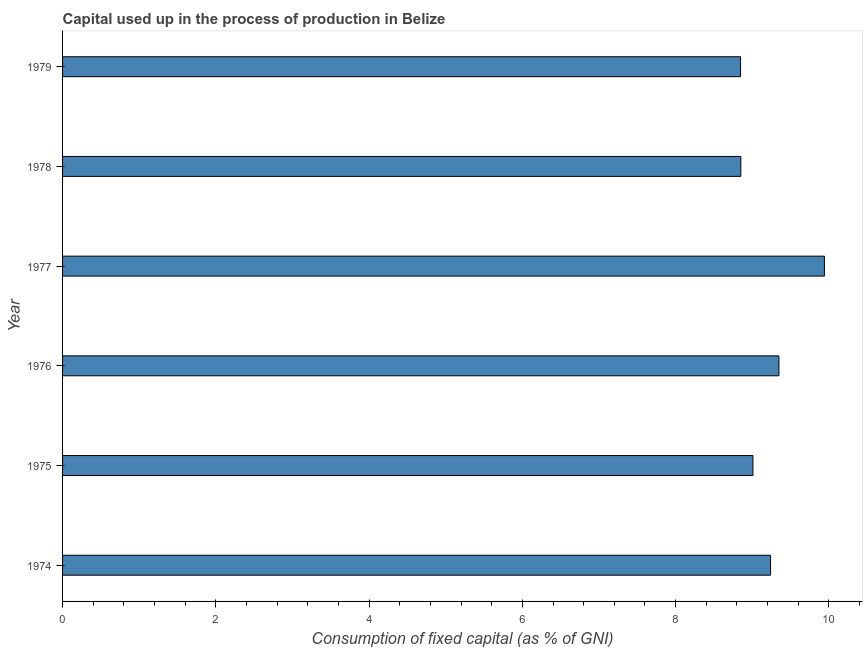Does the graph contain any zero values?
Offer a terse response. No. What is the title of the graph?
Ensure brevity in your answer.  Capital used up in the process of production in Belize. What is the label or title of the X-axis?
Provide a succinct answer. Consumption of fixed capital (as % of GNI). What is the label or title of the Y-axis?
Provide a short and direct response. Year. What is the consumption of fixed capital in 1977?
Give a very brief answer. 9.94. Across all years, what is the maximum consumption of fixed capital?
Provide a short and direct response. 9.94. Across all years, what is the minimum consumption of fixed capital?
Offer a terse response. 8.85. In which year was the consumption of fixed capital maximum?
Offer a terse response. 1977. In which year was the consumption of fixed capital minimum?
Ensure brevity in your answer.  1979. What is the sum of the consumption of fixed capital?
Your answer should be very brief. 55.23. What is the difference between the consumption of fixed capital in 1974 and 1979?
Give a very brief answer. 0.39. What is the average consumption of fixed capital per year?
Your answer should be compact. 9.21. What is the median consumption of fixed capital?
Give a very brief answer. 9.12. Do a majority of the years between 1977 and 1974 (inclusive) have consumption of fixed capital greater than 8.4 %?
Your answer should be compact. Yes. What is the ratio of the consumption of fixed capital in 1974 to that in 1979?
Give a very brief answer. 1.04. Is the consumption of fixed capital in 1975 less than that in 1979?
Your answer should be very brief. No. What is the difference between the highest and the second highest consumption of fixed capital?
Offer a terse response. 0.59. Is the sum of the consumption of fixed capital in 1975 and 1979 greater than the maximum consumption of fixed capital across all years?
Provide a succinct answer. Yes. What is the difference between the highest and the lowest consumption of fixed capital?
Your answer should be compact. 1.09. Are all the bars in the graph horizontal?
Offer a very short reply. Yes. How many years are there in the graph?
Your answer should be compact. 6. What is the Consumption of fixed capital (as % of GNI) of 1974?
Keep it short and to the point. 9.24. What is the Consumption of fixed capital (as % of GNI) in 1975?
Offer a terse response. 9.01. What is the Consumption of fixed capital (as % of GNI) of 1976?
Your answer should be compact. 9.35. What is the Consumption of fixed capital (as % of GNI) in 1977?
Your answer should be very brief. 9.94. What is the Consumption of fixed capital (as % of GNI) of 1978?
Provide a succinct answer. 8.85. What is the Consumption of fixed capital (as % of GNI) of 1979?
Offer a terse response. 8.85. What is the difference between the Consumption of fixed capital (as % of GNI) in 1974 and 1975?
Ensure brevity in your answer.  0.23. What is the difference between the Consumption of fixed capital (as % of GNI) in 1974 and 1976?
Your response must be concise. -0.11. What is the difference between the Consumption of fixed capital (as % of GNI) in 1974 and 1977?
Give a very brief answer. -0.7. What is the difference between the Consumption of fixed capital (as % of GNI) in 1974 and 1978?
Offer a very short reply. 0.39. What is the difference between the Consumption of fixed capital (as % of GNI) in 1974 and 1979?
Make the answer very short. 0.39. What is the difference between the Consumption of fixed capital (as % of GNI) in 1975 and 1976?
Ensure brevity in your answer.  -0.34. What is the difference between the Consumption of fixed capital (as % of GNI) in 1975 and 1977?
Keep it short and to the point. -0.93. What is the difference between the Consumption of fixed capital (as % of GNI) in 1975 and 1978?
Offer a terse response. 0.16. What is the difference between the Consumption of fixed capital (as % of GNI) in 1975 and 1979?
Your response must be concise. 0.16. What is the difference between the Consumption of fixed capital (as % of GNI) in 1976 and 1977?
Keep it short and to the point. -0.59. What is the difference between the Consumption of fixed capital (as % of GNI) in 1976 and 1978?
Keep it short and to the point. 0.5. What is the difference between the Consumption of fixed capital (as % of GNI) in 1976 and 1979?
Ensure brevity in your answer.  0.5. What is the difference between the Consumption of fixed capital (as % of GNI) in 1977 and 1978?
Offer a terse response. 1.09. What is the difference between the Consumption of fixed capital (as % of GNI) in 1977 and 1979?
Make the answer very short. 1.09. What is the difference between the Consumption of fixed capital (as % of GNI) in 1978 and 1979?
Keep it short and to the point. 0. What is the ratio of the Consumption of fixed capital (as % of GNI) in 1974 to that in 1975?
Make the answer very short. 1.02. What is the ratio of the Consumption of fixed capital (as % of GNI) in 1974 to that in 1976?
Ensure brevity in your answer.  0.99. What is the ratio of the Consumption of fixed capital (as % of GNI) in 1974 to that in 1977?
Offer a very short reply. 0.93. What is the ratio of the Consumption of fixed capital (as % of GNI) in 1974 to that in 1978?
Your answer should be compact. 1.04. What is the ratio of the Consumption of fixed capital (as % of GNI) in 1974 to that in 1979?
Give a very brief answer. 1.04. What is the ratio of the Consumption of fixed capital (as % of GNI) in 1975 to that in 1976?
Give a very brief answer. 0.96. What is the ratio of the Consumption of fixed capital (as % of GNI) in 1975 to that in 1977?
Ensure brevity in your answer.  0.91. What is the ratio of the Consumption of fixed capital (as % of GNI) in 1976 to that in 1978?
Keep it short and to the point. 1.06. What is the ratio of the Consumption of fixed capital (as % of GNI) in 1976 to that in 1979?
Your answer should be compact. 1.06. What is the ratio of the Consumption of fixed capital (as % of GNI) in 1977 to that in 1978?
Your response must be concise. 1.12. What is the ratio of the Consumption of fixed capital (as % of GNI) in 1977 to that in 1979?
Make the answer very short. 1.12. 